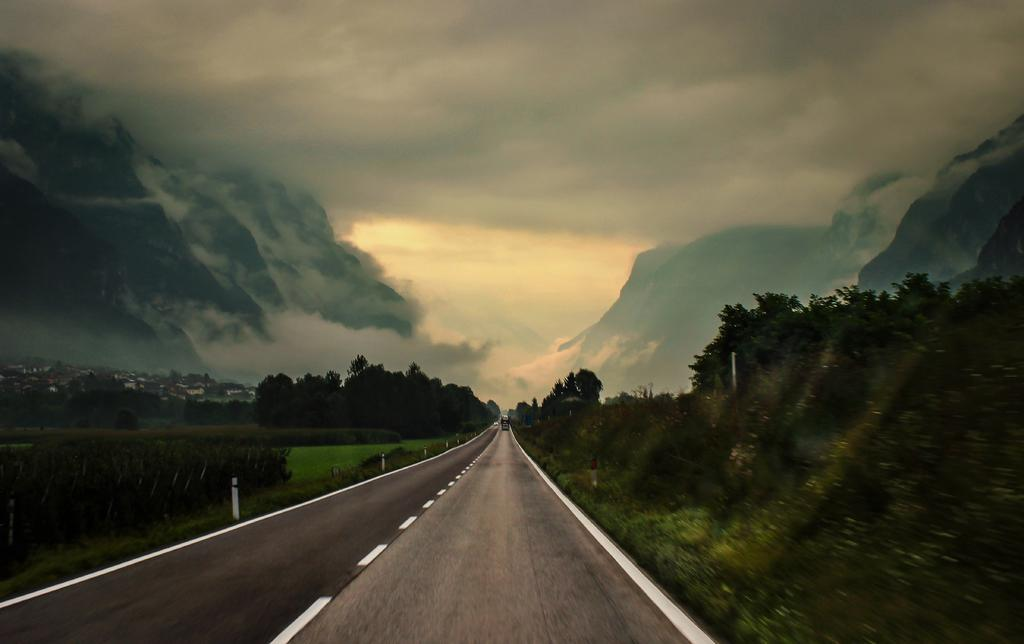What type of vegetation is visible in the image? There are trees in the image. What is covering the ground in the image? There is grass on the ground in the image. What is the condition of the sky in the image? The sky is cloudy in the image. How many screws can be seen holding the bird to the tree in the image? There are no screws or birds present in the image; it features trees and grass. 